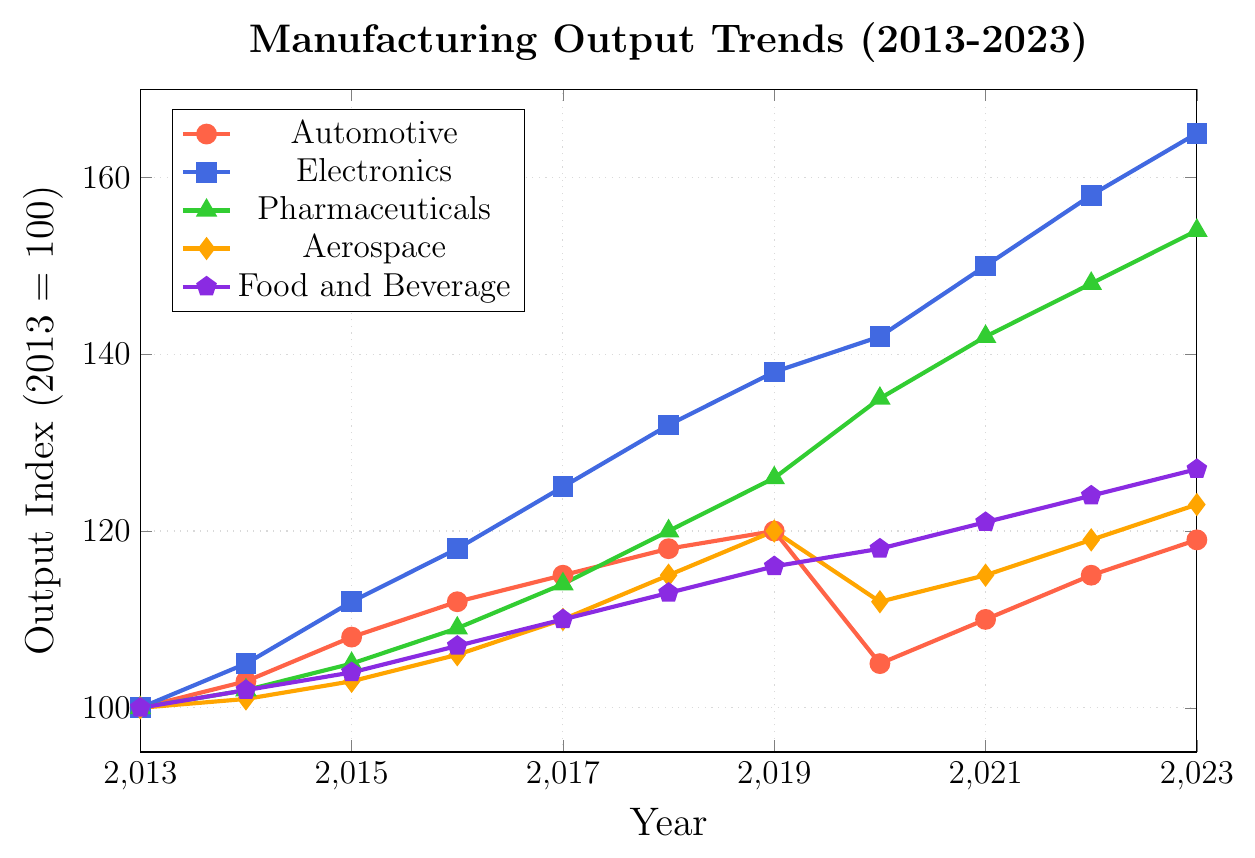what was the highest output index achieved for Electronics over the decade? By looking at the line for Electronics, we see that it reaches its peak at the point corresponding to the year 2023, at an output index value of 165.
Answer: 165 Compare the output index for Pharmaceuticals and Aerospace in the year 2019. Which industry had a higher output and by how much? In 2019, the output index for Pharmaceuticals is 126, and for Aerospace, it is 120. The difference is 126 - 120 = 6. Pharmaceuticals had a higher output by 6.
Answer: Pharmaceuticals, by 6 By how much did the Automotive industry output decrease from 2019 to 2020? The output index for the Automotive industry in 2019 is 120, and in 2020 it is 105. The decrease is 120 - 105 = 15.
Answer: 15 Which industry showed the most consistent year-over-year increase? The industry with the line that consistently moves upward without any dips is the Food and Beverage industry. The line continuously increases each year.
Answer: Food and Beverage Calculate the average output index for the Aerospace industry for the years 2020, 2021, and 2022. The output indices for Aerospace are 112 in 2020, 115 in 2021, and 119 in 2022. The average is (112 + 115 + 119) / 3 = 346 / 3 ≈ 115.33.
Answer: 115.33 Between 2013 and 2023, which year saw the most significant increase in the output index for Pharmaceuticals? The sharpest increase for Pharmaceuticals happened between 2019 and 2020, jumping from an index of 126 to 135.
Answer: Between 2019 and 2020 Which industry experienced a drop in output index during 2020, and what was the decrease? Both the Automotive and Aerospace industries experienced a drop in 2020. Automotive decreased from 120 to 105 (a drop of 15), and Aerospace decreased from 120 to 112 (a drop of 8). The Automotive industry had a more significant drop.
Answer: Automotive, 15 